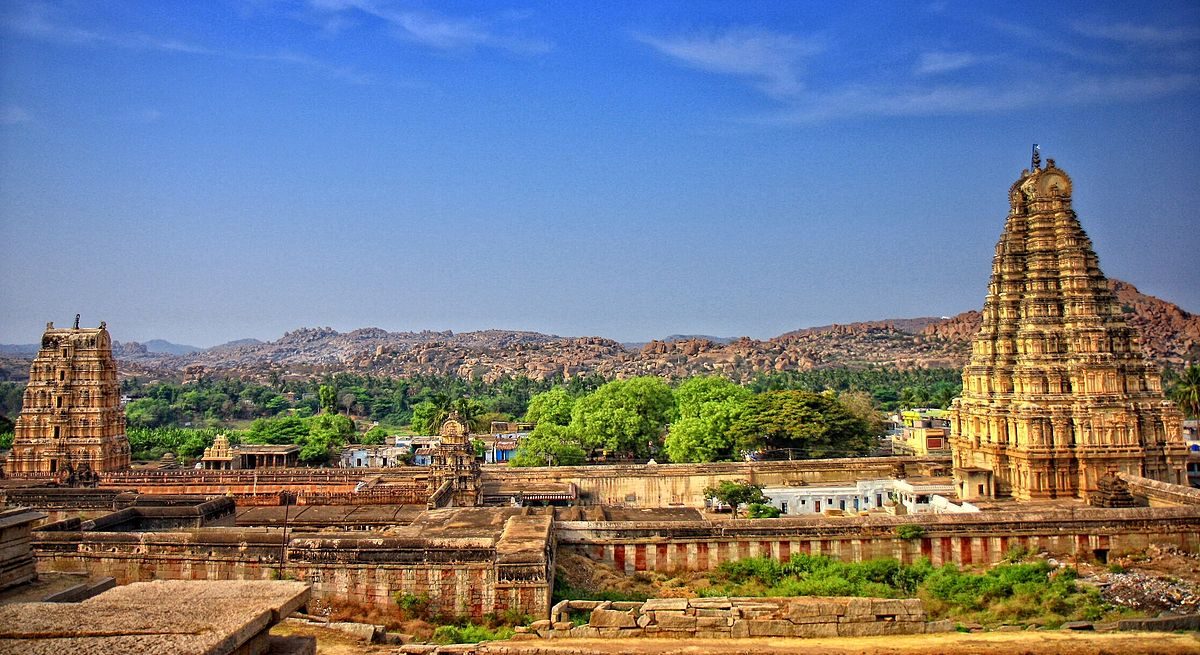Write a detailed description of the given image. The image captures the grandeur of the Virupaksha Temple, a revered Hindu temple nestled in the historic ruins of Hampi, India, which stands as one of the oldest functioning temples dedicated to Lord Shiva. The photograph, taken from a high vantage point, offers a wide panoramic view of the temple complex against a backdrop of rolling, rocky hills and lush greenery.

The scene is dominated by the temple’s tall and majestic gopurams (temple towers), adorned with intricate carvings that reflect the architectural ingenuity of ancient India. These towers reach high into a clear blue sky, with their warm, earthy tones contrasting beautifully against the cool hues of the atmosphere.

The perspective of the image allows for an appreciation of not just the scale, but also the architectural brilliance of the entire temple complex, highlighting the rich cultural heritage and artistic prowess of the era. The sprawling landscape around the temple, peppered with bright green vegetation, seamlessly blends natural beauty with the man-made marvels, enhancing the aesthetic and historical value of the photograph. This image is a vivid testament to the enduring legacy of ancient Indian architecture and spirituality. 